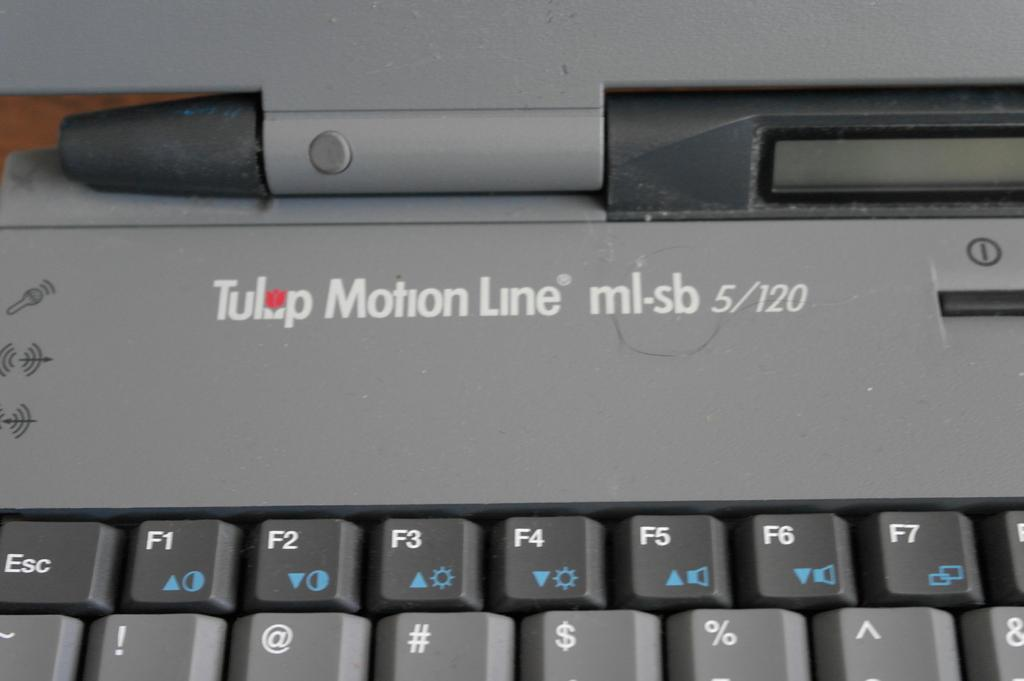<image>
Summarize the visual content of the image. A tulip motion line ml-sb 5/120 computer with the f1-f7 buttons showing 